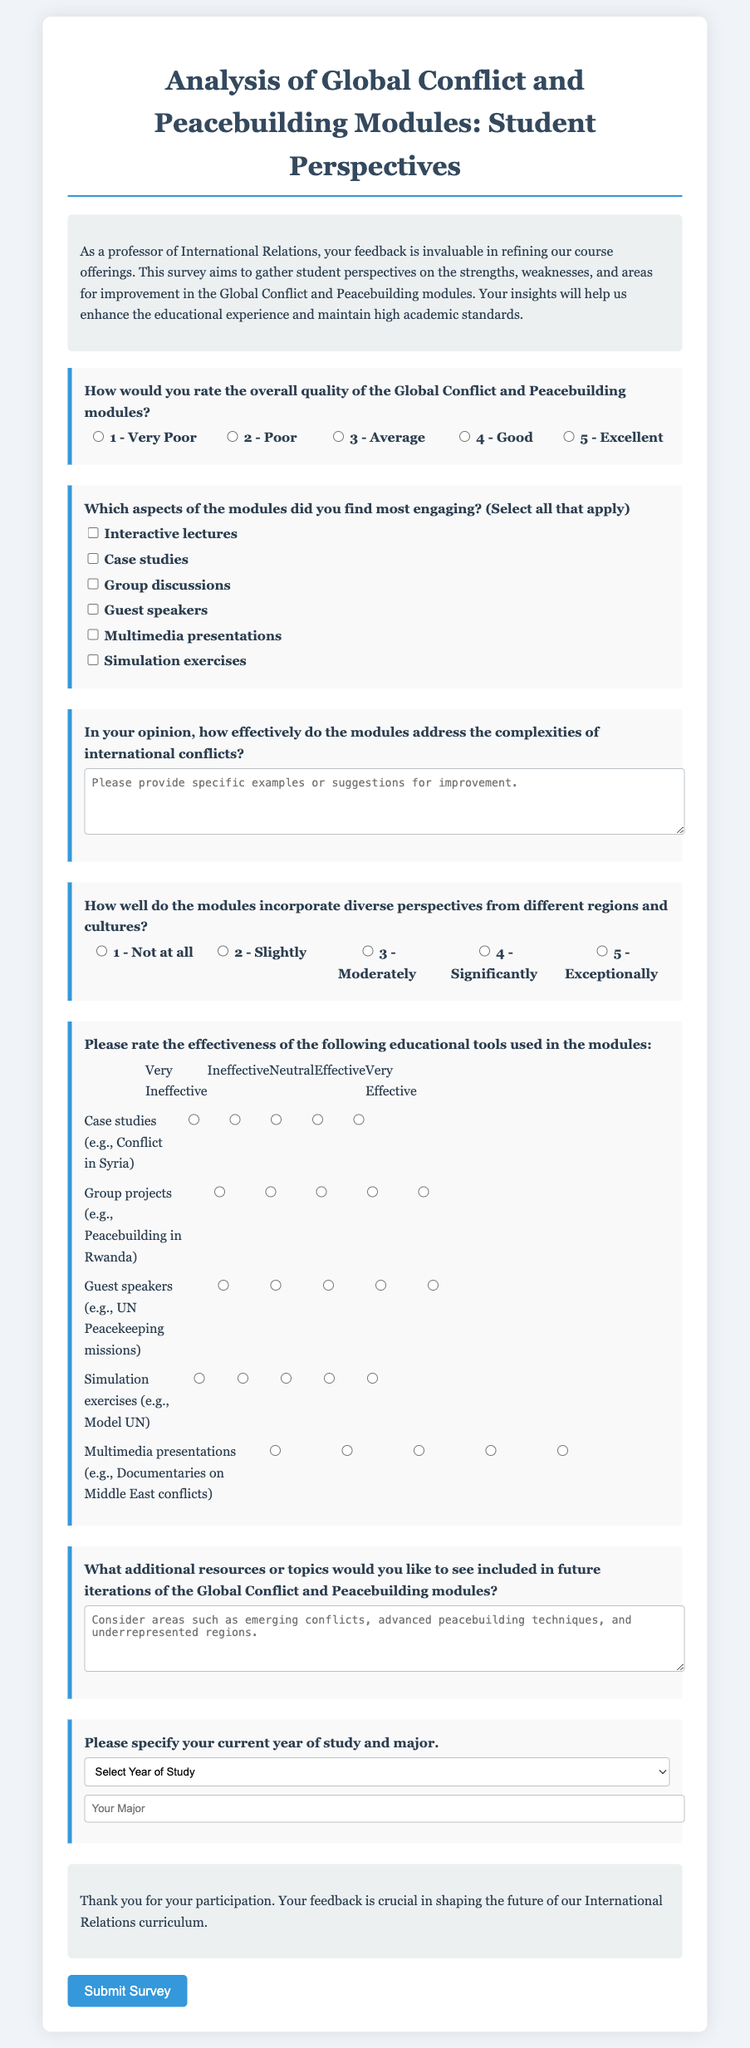What is the title of the survey? The title of the survey is located at the top of the document.
Answer: Analysis of Global Conflict and Peacebuilding Modules: Student Perspectives How many radio buttons are provided for rating overall quality? The document indicates the number of radio buttons for overall quality of the modules.
Answer: 5 What aspect is mentioned as a way to engage students in the modules? This aspect can be found in a checkbox section of the survey form.
Answer: Interactive lectures What educational tool is associated with the case studies? The educational tool mentioned in relation to case studies is provided in the matrix section.
Answer: Conflict in Syria How does the survey ask for diversity perspective rating? The survey asks respondents to rate diversity perspectives through a specific type of question format.
Answer: Radio buttons What type of feedback does the survey focus on? This type of feedback is described in the introduction of the document.
Answer: Student perspectives What is one of the additional resources topics suggested for future iterations? The document asks for additional topics, which can be found in a specified question section.
Answer: Emerging conflicts How are the answers for educational tools rated? The answers for educational tools are rated using a certain method outlined in the survey.
Answer: Matrix of radio buttons 